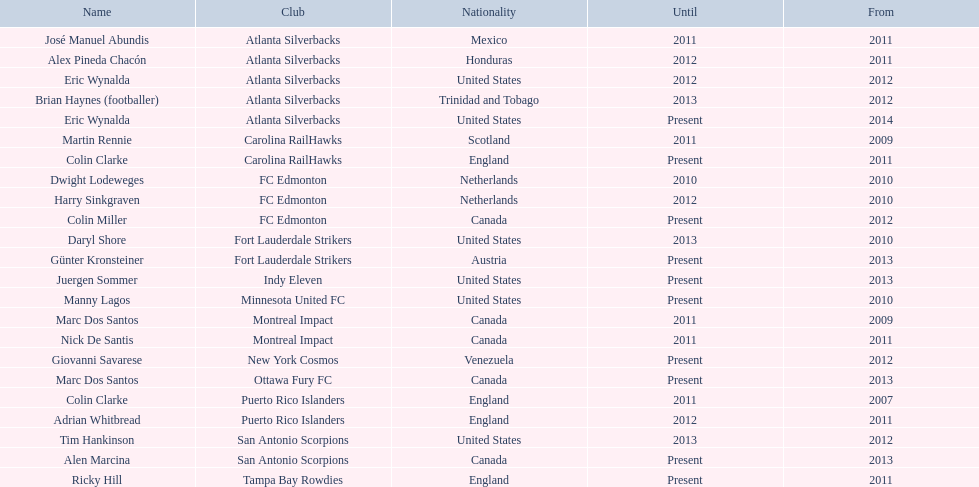What year did marc dos santos start as coach? 2009. Besides marc dos santos, what other coach started in 2009? Martin Rennie. 